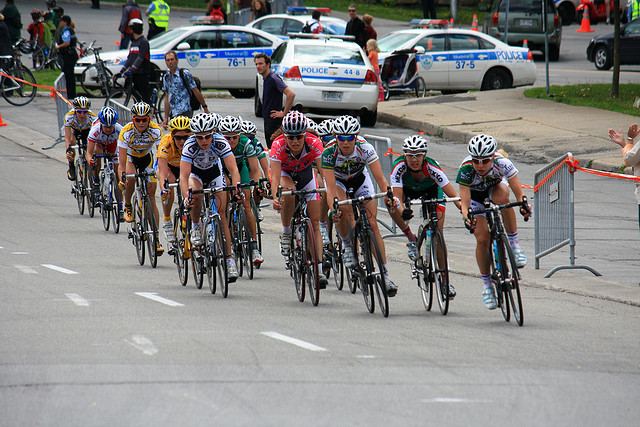Read and extract the text from this image. 76 POLICE 37-5 